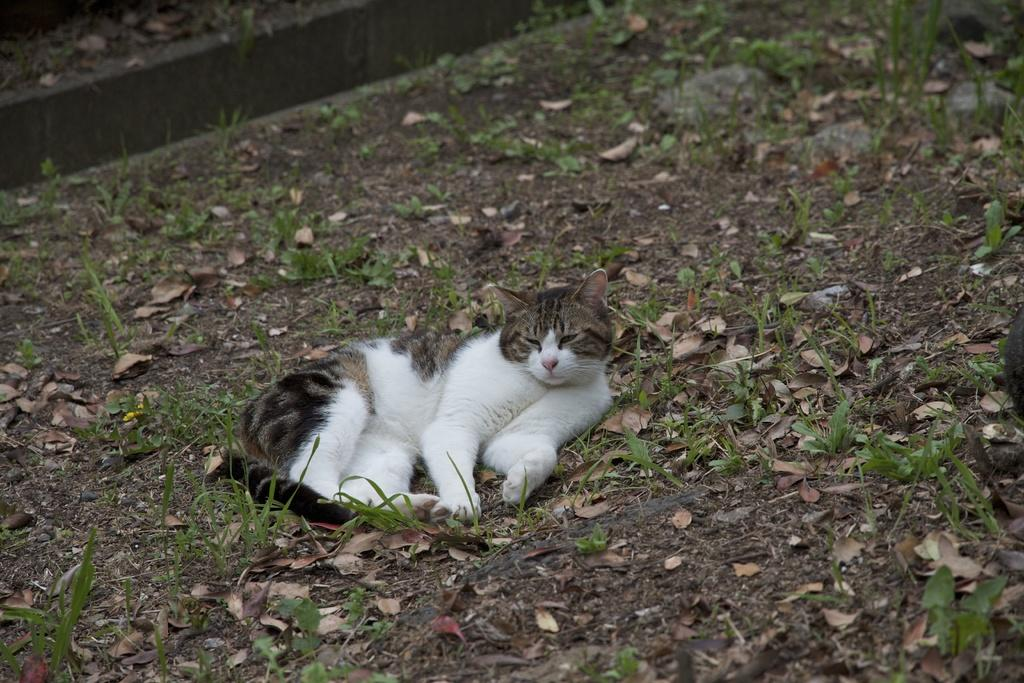What is the main subject in the center of the image? There is a cat in the center of the image. What type of natural environment is visible in the image? There is grass visible in the image. What other elements can be seen in the image? Leaves are present in the image. What type of bun is the cat holding in its mouth in the image? There is no bun present in the image, and the cat is not holding anything in its mouth. Can you tell me how many times the cat bites the guitar in the image? There is no guitar present in the image, so the cat cannot bite it. 